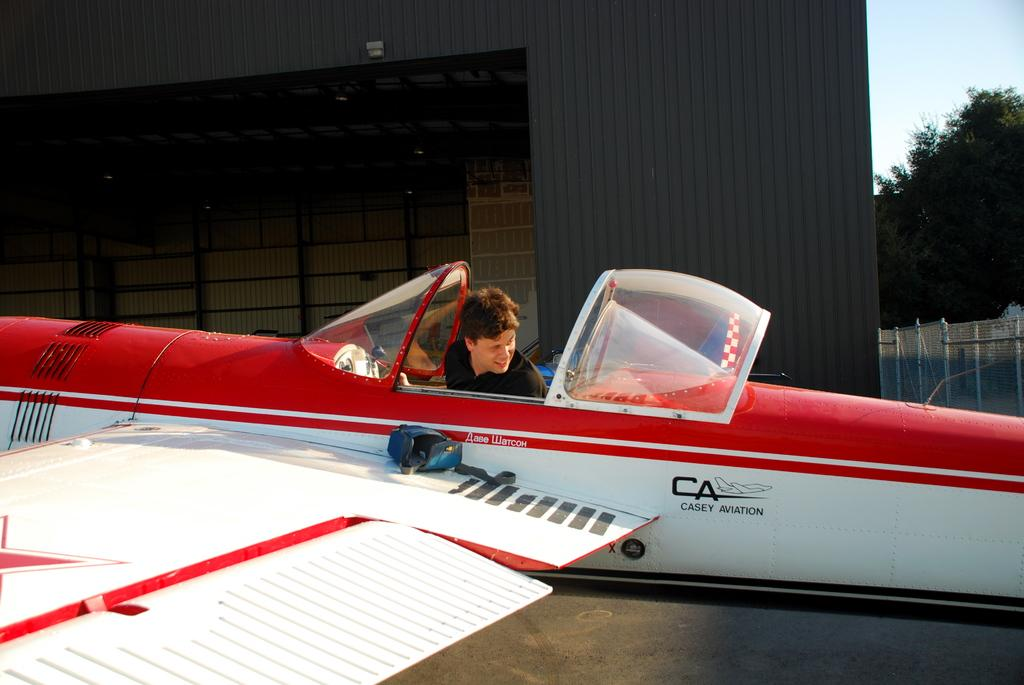<image>
Render a clear and concise summary of the photo. A man is in the open cockpit of a Casey Aviation airplane. 